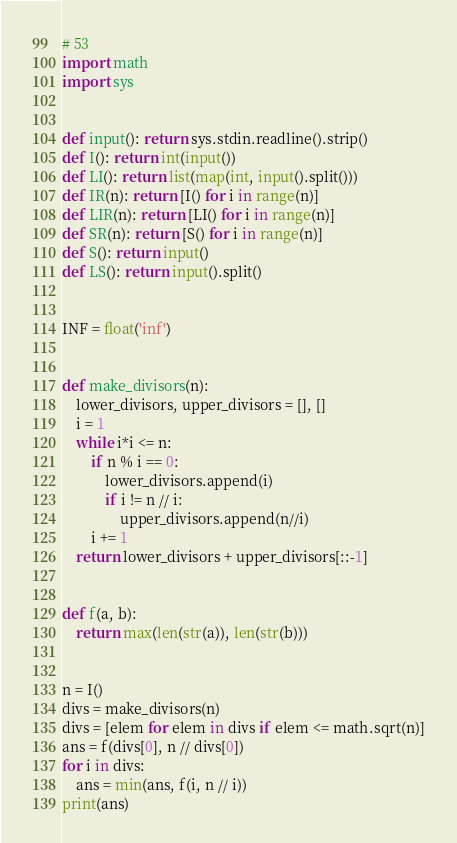Convert code to text. <code><loc_0><loc_0><loc_500><loc_500><_Python_># 53
import math
import sys


def input(): return sys.stdin.readline().strip()
def I(): return int(input())
def LI(): return list(map(int, input().split()))
def IR(n): return [I() for i in range(n)]
def LIR(n): return [LI() for i in range(n)]
def SR(n): return [S() for i in range(n)]
def S(): return input()
def LS(): return input().split()


INF = float('inf')


def make_divisors(n):
    lower_divisors, upper_divisors = [], []
    i = 1
    while i*i <= n:
        if n % i == 0:
            lower_divisors.append(i)
            if i != n // i:
                upper_divisors.append(n//i)
        i += 1
    return lower_divisors + upper_divisors[::-1]


def f(a, b):
    return max(len(str(a)), len(str(b)))


n = I()
divs = make_divisors(n)
divs = [elem for elem in divs if elem <= math.sqrt(n)]
ans = f(divs[0], n // divs[0])
for i in divs:
    ans = min(ans, f(i, n // i))
print(ans)
</code> 